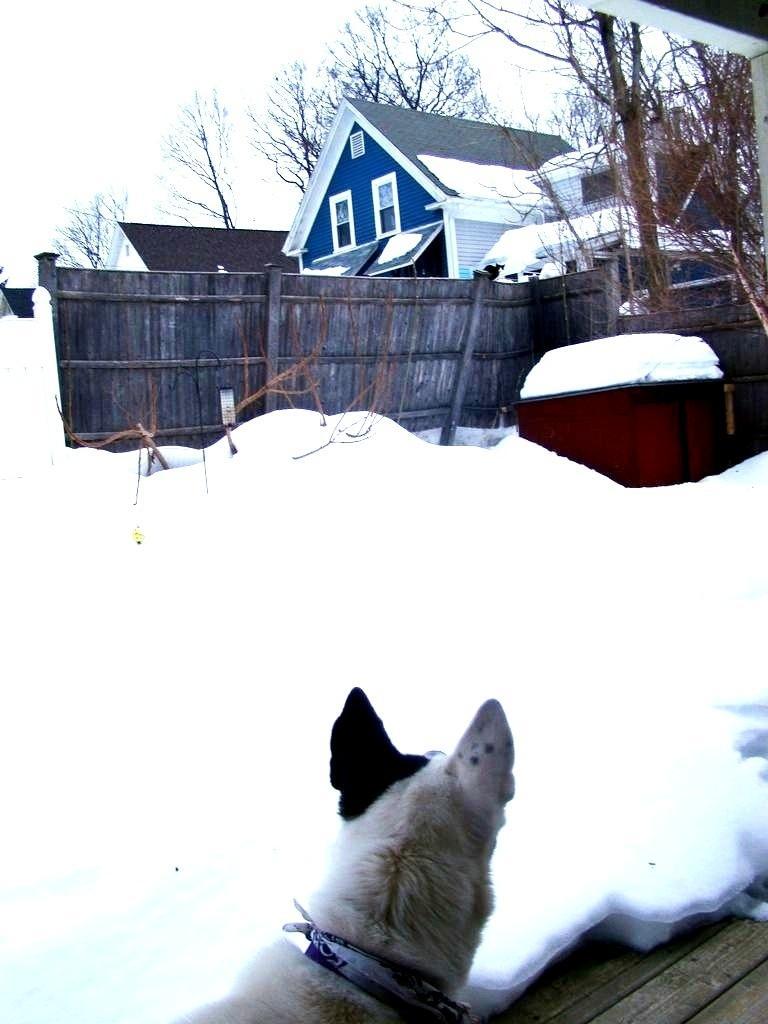In one or two sentences, can you explain what this image depicts? In this image we can see buildings, fences, trees and ground which are covered with snow. In the background we can see sky. 